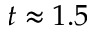<formula> <loc_0><loc_0><loc_500><loc_500>t \approx 1 . 5</formula> 